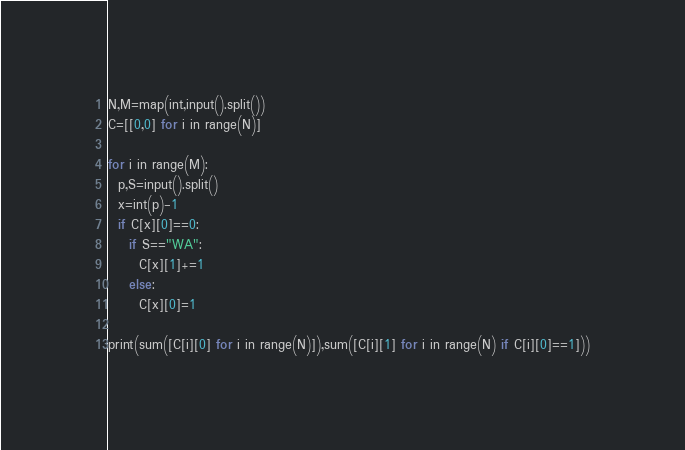<code> <loc_0><loc_0><loc_500><loc_500><_Python_>N,M=map(int,input().split())
C=[[0,0] for i in range(N)]

for i in range(M):
  p,S=input().split()
  x=int(p)-1
  if C[x][0]==0:
    if S=="WA":
      C[x][1]+=1
    else:
      C[x][0]=1

print(sum([C[i][0] for i in range(N)]),sum([C[i][1] for i in range(N) if C[i][0]==1]))
</code> 